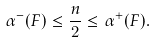Convert formula to latex. <formula><loc_0><loc_0><loc_500><loc_500>\alpha ^ { - } ( F ) \leq \frac { n } { 2 } \leq \alpha ^ { + } ( F ) .</formula> 